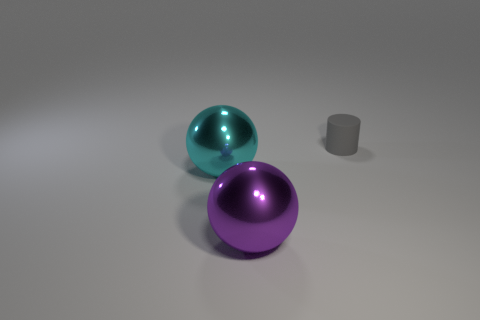What material is the tiny gray cylinder that is behind the large cyan ball that is behind the large shiny thing to the right of the big cyan shiny sphere?
Ensure brevity in your answer.  Rubber. What number of purple things are either rubber cylinders or spheres?
Make the answer very short. 1. There is a purple metal sphere that is in front of the large object behind the big metal sphere that is on the right side of the cyan object; what is its size?
Your response must be concise. Large. What number of large objects are blue metallic objects or rubber things?
Ensure brevity in your answer.  0. Do the sphere on the right side of the cyan object and the thing that is on the left side of the big purple metal ball have the same material?
Provide a short and direct response. Yes. There is a big sphere behind the purple shiny object; what is it made of?
Your response must be concise. Metal. What number of shiny objects are either cylinders or small gray balls?
Ensure brevity in your answer.  0. There is a thing that is left of the sphere that is in front of the cyan metallic object; what is its color?
Your answer should be compact. Cyan. Does the small gray object have the same material as the ball that is in front of the cyan sphere?
Your response must be concise. No. The large metal ball behind the ball that is in front of the metal sphere that is behind the large purple ball is what color?
Make the answer very short. Cyan. 